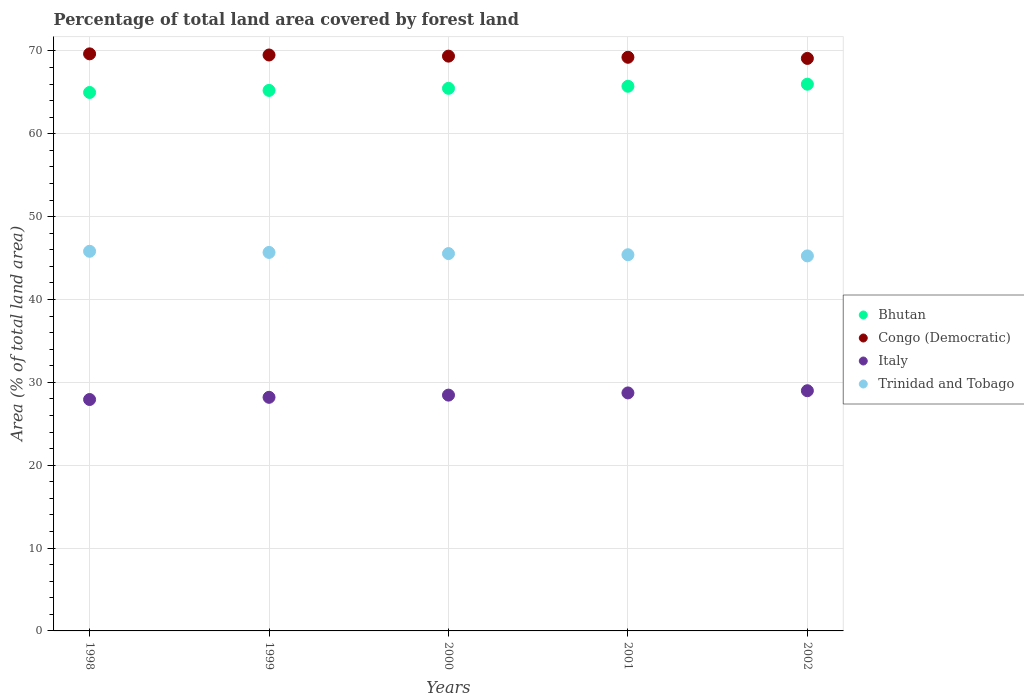What is the percentage of forest land in Congo (Democratic) in 1999?
Offer a terse response. 69.5. Across all years, what is the maximum percentage of forest land in Italy?
Your response must be concise. 28.99. Across all years, what is the minimum percentage of forest land in Bhutan?
Offer a terse response. 64.98. In which year was the percentage of forest land in Trinidad and Tobago maximum?
Your answer should be compact. 1998. In which year was the percentage of forest land in Bhutan minimum?
Offer a very short reply. 1998. What is the total percentage of forest land in Italy in the graph?
Your answer should be compact. 142.28. What is the difference between the percentage of forest land in Italy in 1999 and that in 2002?
Your answer should be very brief. -0.8. What is the difference between the percentage of forest land in Italy in 1998 and the percentage of forest land in Bhutan in 1999?
Provide a short and direct response. -37.3. What is the average percentage of forest land in Bhutan per year?
Your response must be concise. 65.48. In the year 1998, what is the difference between the percentage of forest land in Bhutan and percentage of forest land in Congo (Democratic)?
Provide a short and direct response. -4.66. What is the ratio of the percentage of forest land in Congo (Democratic) in 1998 to that in 2002?
Provide a short and direct response. 1.01. What is the difference between the highest and the second highest percentage of forest land in Congo (Democratic)?
Keep it short and to the point. 0.14. What is the difference between the highest and the lowest percentage of forest land in Congo (Democratic)?
Offer a very short reply. 0.55. In how many years, is the percentage of forest land in Trinidad and Tobago greater than the average percentage of forest land in Trinidad and Tobago taken over all years?
Your answer should be compact. 3. Is it the case that in every year, the sum of the percentage of forest land in Trinidad and Tobago and percentage of forest land in Congo (Democratic)  is greater than the sum of percentage of forest land in Bhutan and percentage of forest land in Italy?
Offer a terse response. No. Is it the case that in every year, the sum of the percentage of forest land in Bhutan and percentage of forest land in Italy  is greater than the percentage of forest land in Congo (Democratic)?
Provide a succinct answer. Yes. Does the percentage of forest land in Bhutan monotonically increase over the years?
Your answer should be compact. Yes. Is the percentage of forest land in Trinidad and Tobago strictly less than the percentage of forest land in Congo (Democratic) over the years?
Give a very brief answer. Yes. Are the values on the major ticks of Y-axis written in scientific E-notation?
Ensure brevity in your answer.  No. Does the graph contain any zero values?
Ensure brevity in your answer.  No. Does the graph contain grids?
Give a very brief answer. Yes. Where does the legend appear in the graph?
Your answer should be very brief. Center right. What is the title of the graph?
Make the answer very short. Percentage of total land area covered by forest land. Does "Samoa" appear as one of the legend labels in the graph?
Provide a short and direct response. No. What is the label or title of the Y-axis?
Offer a terse response. Area (% of total land area). What is the Area (% of total land area) of Bhutan in 1998?
Keep it short and to the point. 64.98. What is the Area (% of total land area) in Congo (Democratic) in 1998?
Offer a very short reply. 69.64. What is the Area (% of total land area) in Italy in 1998?
Make the answer very short. 27.93. What is the Area (% of total land area) in Trinidad and Tobago in 1998?
Make the answer very short. 45.81. What is the Area (% of total land area) in Bhutan in 1999?
Your response must be concise. 65.23. What is the Area (% of total land area) in Congo (Democratic) in 1999?
Provide a succinct answer. 69.5. What is the Area (% of total land area) in Italy in 1999?
Offer a terse response. 28.19. What is the Area (% of total land area) in Trinidad and Tobago in 1999?
Offer a terse response. 45.67. What is the Area (% of total land area) in Bhutan in 2000?
Offer a terse response. 65.48. What is the Area (% of total land area) in Congo (Democratic) in 2000?
Ensure brevity in your answer.  69.36. What is the Area (% of total land area) of Italy in 2000?
Your response must be concise. 28.46. What is the Area (% of total land area) of Trinidad and Tobago in 2000?
Your response must be concise. 45.54. What is the Area (% of total land area) in Bhutan in 2001?
Your answer should be compact. 65.73. What is the Area (% of total land area) of Congo (Democratic) in 2001?
Provide a short and direct response. 69.23. What is the Area (% of total land area) of Italy in 2001?
Offer a very short reply. 28.72. What is the Area (% of total land area) in Trinidad and Tobago in 2001?
Make the answer very short. 45.4. What is the Area (% of total land area) in Bhutan in 2002?
Ensure brevity in your answer.  65.98. What is the Area (% of total land area) of Congo (Democratic) in 2002?
Your answer should be compact. 69.09. What is the Area (% of total land area) of Italy in 2002?
Your answer should be compact. 28.99. What is the Area (% of total land area) in Trinidad and Tobago in 2002?
Your answer should be compact. 45.26. Across all years, what is the maximum Area (% of total land area) in Bhutan?
Your answer should be very brief. 65.98. Across all years, what is the maximum Area (% of total land area) of Congo (Democratic)?
Ensure brevity in your answer.  69.64. Across all years, what is the maximum Area (% of total land area) in Italy?
Provide a short and direct response. 28.99. Across all years, what is the maximum Area (% of total land area) of Trinidad and Tobago?
Your answer should be very brief. 45.81. Across all years, what is the minimum Area (% of total land area) in Bhutan?
Provide a succinct answer. 64.98. Across all years, what is the minimum Area (% of total land area) of Congo (Democratic)?
Your answer should be compact. 69.09. Across all years, what is the minimum Area (% of total land area) of Italy?
Provide a short and direct response. 27.93. Across all years, what is the minimum Area (% of total land area) in Trinidad and Tobago?
Keep it short and to the point. 45.26. What is the total Area (% of total land area) in Bhutan in the graph?
Give a very brief answer. 327.39. What is the total Area (% of total land area) of Congo (Democratic) in the graph?
Offer a terse response. 346.81. What is the total Area (% of total land area) in Italy in the graph?
Give a very brief answer. 142.28. What is the total Area (% of total land area) of Trinidad and Tobago in the graph?
Make the answer very short. 227.67. What is the difference between the Area (% of total land area) of Bhutan in 1998 and that in 1999?
Make the answer very short. -0.25. What is the difference between the Area (% of total land area) in Congo (Democratic) in 1998 and that in 1999?
Offer a terse response. 0.14. What is the difference between the Area (% of total land area) of Italy in 1998 and that in 1999?
Your answer should be compact. -0.26. What is the difference between the Area (% of total land area) of Trinidad and Tobago in 1998 and that in 1999?
Give a very brief answer. 0.14. What is the difference between the Area (% of total land area) in Bhutan in 1998 and that in 2000?
Make the answer very short. -0.5. What is the difference between the Area (% of total land area) of Congo (Democratic) in 1998 and that in 2000?
Your answer should be compact. 0.27. What is the difference between the Area (% of total land area) of Italy in 1998 and that in 2000?
Give a very brief answer. -0.53. What is the difference between the Area (% of total land area) of Trinidad and Tobago in 1998 and that in 2000?
Offer a terse response. 0.28. What is the difference between the Area (% of total land area) in Bhutan in 1998 and that in 2001?
Your answer should be very brief. -0.75. What is the difference between the Area (% of total land area) of Congo (Democratic) in 1998 and that in 2001?
Your answer should be compact. 0.41. What is the difference between the Area (% of total land area) in Italy in 1998 and that in 2001?
Offer a terse response. -0.79. What is the difference between the Area (% of total land area) in Trinidad and Tobago in 1998 and that in 2001?
Your answer should be compact. 0.42. What is the difference between the Area (% of total land area) of Bhutan in 1998 and that in 2002?
Offer a terse response. -1. What is the difference between the Area (% of total land area) in Congo (Democratic) in 1998 and that in 2002?
Ensure brevity in your answer.  0.55. What is the difference between the Area (% of total land area) in Italy in 1998 and that in 2002?
Provide a succinct answer. -1.06. What is the difference between the Area (% of total land area) in Trinidad and Tobago in 1998 and that in 2002?
Offer a very short reply. 0.56. What is the difference between the Area (% of total land area) in Bhutan in 1999 and that in 2000?
Offer a terse response. -0.25. What is the difference between the Area (% of total land area) in Congo (Democratic) in 1999 and that in 2000?
Offer a very short reply. 0.14. What is the difference between the Area (% of total land area) of Italy in 1999 and that in 2000?
Keep it short and to the point. -0.26. What is the difference between the Area (% of total land area) in Trinidad and Tobago in 1999 and that in 2000?
Give a very brief answer. 0.14. What is the difference between the Area (% of total land area) in Bhutan in 1999 and that in 2001?
Provide a short and direct response. -0.5. What is the difference between the Area (% of total land area) in Congo (Democratic) in 1999 and that in 2001?
Keep it short and to the point. 0.27. What is the difference between the Area (% of total land area) in Italy in 1999 and that in 2001?
Give a very brief answer. -0.53. What is the difference between the Area (% of total land area) of Trinidad and Tobago in 1999 and that in 2001?
Your response must be concise. 0.28. What is the difference between the Area (% of total land area) of Bhutan in 1999 and that in 2002?
Make the answer very short. -0.75. What is the difference between the Area (% of total land area) of Congo (Democratic) in 1999 and that in 2002?
Keep it short and to the point. 0.41. What is the difference between the Area (% of total land area) of Italy in 1999 and that in 2002?
Provide a short and direct response. -0.8. What is the difference between the Area (% of total land area) of Trinidad and Tobago in 1999 and that in 2002?
Keep it short and to the point. 0.42. What is the difference between the Area (% of total land area) of Bhutan in 2000 and that in 2001?
Ensure brevity in your answer.  -0.25. What is the difference between the Area (% of total land area) in Congo (Democratic) in 2000 and that in 2001?
Your response must be concise. 0.14. What is the difference between the Area (% of total land area) of Italy in 2000 and that in 2001?
Your response must be concise. -0.27. What is the difference between the Area (% of total land area) in Trinidad and Tobago in 2000 and that in 2001?
Your answer should be compact. 0.14. What is the difference between the Area (% of total land area) in Bhutan in 2000 and that in 2002?
Give a very brief answer. -0.5. What is the difference between the Area (% of total land area) in Congo (Democratic) in 2000 and that in 2002?
Offer a terse response. 0.27. What is the difference between the Area (% of total land area) of Italy in 2000 and that in 2002?
Keep it short and to the point. -0.53. What is the difference between the Area (% of total land area) in Trinidad and Tobago in 2000 and that in 2002?
Provide a short and direct response. 0.28. What is the difference between the Area (% of total land area) of Bhutan in 2001 and that in 2002?
Provide a short and direct response. -0.25. What is the difference between the Area (% of total land area) in Congo (Democratic) in 2001 and that in 2002?
Offer a very short reply. 0.14. What is the difference between the Area (% of total land area) in Italy in 2001 and that in 2002?
Give a very brief answer. -0.27. What is the difference between the Area (% of total land area) in Trinidad and Tobago in 2001 and that in 2002?
Your answer should be compact. 0.14. What is the difference between the Area (% of total land area) of Bhutan in 1998 and the Area (% of total land area) of Congo (Democratic) in 1999?
Make the answer very short. -4.52. What is the difference between the Area (% of total land area) in Bhutan in 1998 and the Area (% of total land area) in Italy in 1999?
Keep it short and to the point. 36.79. What is the difference between the Area (% of total land area) in Bhutan in 1998 and the Area (% of total land area) in Trinidad and Tobago in 1999?
Your answer should be very brief. 19.3. What is the difference between the Area (% of total land area) in Congo (Democratic) in 1998 and the Area (% of total land area) in Italy in 1999?
Your answer should be compact. 41.45. What is the difference between the Area (% of total land area) of Congo (Democratic) in 1998 and the Area (% of total land area) of Trinidad and Tobago in 1999?
Your answer should be compact. 23.96. What is the difference between the Area (% of total land area) of Italy in 1998 and the Area (% of total land area) of Trinidad and Tobago in 1999?
Provide a succinct answer. -17.75. What is the difference between the Area (% of total land area) of Bhutan in 1998 and the Area (% of total land area) of Congo (Democratic) in 2000?
Provide a succinct answer. -4.38. What is the difference between the Area (% of total land area) of Bhutan in 1998 and the Area (% of total land area) of Italy in 2000?
Provide a short and direct response. 36.52. What is the difference between the Area (% of total land area) in Bhutan in 1998 and the Area (% of total land area) in Trinidad and Tobago in 2000?
Offer a terse response. 19.44. What is the difference between the Area (% of total land area) in Congo (Democratic) in 1998 and the Area (% of total land area) in Italy in 2000?
Make the answer very short. 41.18. What is the difference between the Area (% of total land area) of Congo (Democratic) in 1998 and the Area (% of total land area) of Trinidad and Tobago in 2000?
Provide a short and direct response. 24.1. What is the difference between the Area (% of total land area) of Italy in 1998 and the Area (% of total land area) of Trinidad and Tobago in 2000?
Offer a very short reply. -17.61. What is the difference between the Area (% of total land area) of Bhutan in 1998 and the Area (% of total land area) of Congo (Democratic) in 2001?
Ensure brevity in your answer.  -4.25. What is the difference between the Area (% of total land area) in Bhutan in 1998 and the Area (% of total land area) in Italy in 2001?
Give a very brief answer. 36.26. What is the difference between the Area (% of total land area) in Bhutan in 1998 and the Area (% of total land area) in Trinidad and Tobago in 2001?
Provide a short and direct response. 19.58. What is the difference between the Area (% of total land area) of Congo (Democratic) in 1998 and the Area (% of total land area) of Italy in 2001?
Your answer should be compact. 40.92. What is the difference between the Area (% of total land area) in Congo (Democratic) in 1998 and the Area (% of total land area) in Trinidad and Tobago in 2001?
Provide a short and direct response. 24.24. What is the difference between the Area (% of total land area) of Italy in 1998 and the Area (% of total land area) of Trinidad and Tobago in 2001?
Give a very brief answer. -17.47. What is the difference between the Area (% of total land area) in Bhutan in 1998 and the Area (% of total land area) in Congo (Democratic) in 2002?
Offer a terse response. -4.11. What is the difference between the Area (% of total land area) of Bhutan in 1998 and the Area (% of total land area) of Italy in 2002?
Your answer should be very brief. 35.99. What is the difference between the Area (% of total land area) in Bhutan in 1998 and the Area (% of total land area) in Trinidad and Tobago in 2002?
Your answer should be very brief. 19.72. What is the difference between the Area (% of total land area) in Congo (Democratic) in 1998 and the Area (% of total land area) in Italy in 2002?
Your answer should be compact. 40.65. What is the difference between the Area (% of total land area) of Congo (Democratic) in 1998 and the Area (% of total land area) of Trinidad and Tobago in 2002?
Your answer should be compact. 24.38. What is the difference between the Area (% of total land area) of Italy in 1998 and the Area (% of total land area) of Trinidad and Tobago in 2002?
Offer a terse response. -17.33. What is the difference between the Area (% of total land area) of Bhutan in 1999 and the Area (% of total land area) of Congo (Democratic) in 2000?
Offer a very short reply. -4.13. What is the difference between the Area (% of total land area) of Bhutan in 1999 and the Area (% of total land area) of Italy in 2000?
Provide a short and direct response. 36.77. What is the difference between the Area (% of total land area) in Bhutan in 1999 and the Area (% of total land area) in Trinidad and Tobago in 2000?
Your answer should be compact. 19.69. What is the difference between the Area (% of total land area) of Congo (Democratic) in 1999 and the Area (% of total land area) of Italy in 2000?
Offer a terse response. 41.04. What is the difference between the Area (% of total land area) in Congo (Democratic) in 1999 and the Area (% of total land area) in Trinidad and Tobago in 2000?
Your response must be concise. 23.96. What is the difference between the Area (% of total land area) of Italy in 1999 and the Area (% of total land area) of Trinidad and Tobago in 2000?
Your answer should be very brief. -17.35. What is the difference between the Area (% of total land area) of Bhutan in 1999 and the Area (% of total land area) of Congo (Democratic) in 2001?
Provide a short and direct response. -4. What is the difference between the Area (% of total land area) in Bhutan in 1999 and the Area (% of total land area) in Italy in 2001?
Make the answer very short. 36.51. What is the difference between the Area (% of total land area) in Bhutan in 1999 and the Area (% of total land area) in Trinidad and Tobago in 2001?
Make the answer very short. 19.83. What is the difference between the Area (% of total land area) of Congo (Democratic) in 1999 and the Area (% of total land area) of Italy in 2001?
Give a very brief answer. 40.78. What is the difference between the Area (% of total land area) in Congo (Democratic) in 1999 and the Area (% of total land area) in Trinidad and Tobago in 2001?
Provide a succinct answer. 24.1. What is the difference between the Area (% of total land area) of Italy in 1999 and the Area (% of total land area) of Trinidad and Tobago in 2001?
Offer a terse response. -17.21. What is the difference between the Area (% of total land area) of Bhutan in 1999 and the Area (% of total land area) of Congo (Democratic) in 2002?
Your answer should be compact. -3.86. What is the difference between the Area (% of total land area) of Bhutan in 1999 and the Area (% of total land area) of Italy in 2002?
Make the answer very short. 36.24. What is the difference between the Area (% of total land area) of Bhutan in 1999 and the Area (% of total land area) of Trinidad and Tobago in 2002?
Provide a short and direct response. 19.97. What is the difference between the Area (% of total land area) in Congo (Democratic) in 1999 and the Area (% of total land area) in Italy in 2002?
Keep it short and to the point. 40.51. What is the difference between the Area (% of total land area) in Congo (Democratic) in 1999 and the Area (% of total land area) in Trinidad and Tobago in 2002?
Ensure brevity in your answer.  24.24. What is the difference between the Area (% of total land area) in Italy in 1999 and the Area (% of total land area) in Trinidad and Tobago in 2002?
Your response must be concise. -17.06. What is the difference between the Area (% of total land area) in Bhutan in 2000 and the Area (% of total land area) in Congo (Democratic) in 2001?
Keep it short and to the point. -3.75. What is the difference between the Area (% of total land area) of Bhutan in 2000 and the Area (% of total land area) of Italy in 2001?
Ensure brevity in your answer.  36.76. What is the difference between the Area (% of total land area) of Bhutan in 2000 and the Area (% of total land area) of Trinidad and Tobago in 2001?
Offer a terse response. 20.08. What is the difference between the Area (% of total land area) in Congo (Democratic) in 2000 and the Area (% of total land area) in Italy in 2001?
Offer a terse response. 40.64. What is the difference between the Area (% of total land area) of Congo (Democratic) in 2000 and the Area (% of total land area) of Trinidad and Tobago in 2001?
Make the answer very short. 23.97. What is the difference between the Area (% of total land area) in Italy in 2000 and the Area (% of total land area) in Trinidad and Tobago in 2001?
Provide a short and direct response. -16.94. What is the difference between the Area (% of total land area) in Bhutan in 2000 and the Area (% of total land area) in Congo (Democratic) in 2002?
Provide a short and direct response. -3.61. What is the difference between the Area (% of total land area) in Bhutan in 2000 and the Area (% of total land area) in Italy in 2002?
Your answer should be very brief. 36.49. What is the difference between the Area (% of total land area) of Bhutan in 2000 and the Area (% of total land area) of Trinidad and Tobago in 2002?
Your answer should be compact. 20.22. What is the difference between the Area (% of total land area) in Congo (Democratic) in 2000 and the Area (% of total land area) in Italy in 2002?
Give a very brief answer. 40.38. What is the difference between the Area (% of total land area) in Congo (Democratic) in 2000 and the Area (% of total land area) in Trinidad and Tobago in 2002?
Ensure brevity in your answer.  24.11. What is the difference between the Area (% of total land area) in Italy in 2000 and the Area (% of total land area) in Trinidad and Tobago in 2002?
Ensure brevity in your answer.  -16.8. What is the difference between the Area (% of total land area) of Bhutan in 2001 and the Area (% of total land area) of Congo (Democratic) in 2002?
Offer a very short reply. -3.36. What is the difference between the Area (% of total land area) of Bhutan in 2001 and the Area (% of total land area) of Italy in 2002?
Keep it short and to the point. 36.74. What is the difference between the Area (% of total land area) in Bhutan in 2001 and the Area (% of total land area) in Trinidad and Tobago in 2002?
Give a very brief answer. 20.47. What is the difference between the Area (% of total land area) in Congo (Democratic) in 2001 and the Area (% of total land area) in Italy in 2002?
Keep it short and to the point. 40.24. What is the difference between the Area (% of total land area) of Congo (Democratic) in 2001 and the Area (% of total land area) of Trinidad and Tobago in 2002?
Offer a terse response. 23.97. What is the difference between the Area (% of total land area) of Italy in 2001 and the Area (% of total land area) of Trinidad and Tobago in 2002?
Ensure brevity in your answer.  -16.53. What is the average Area (% of total land area) in Bhutan per year?
Give a very brief answer. 65.48. What is the average Area (% of total land area) in Congo (Democratic) per year?
Give a very brief answer. 69.36. What is the average Area (% of total land area) of Italy per year?
Make the answer very short. 28.46. What is the average Area (% of total land area) in Trinidad and Tobago per year?
Offer a terse response. 45.53. In the year 1998, what is the difference between the Area (% of total land area) in Bhutan and Area (% of total land area) in Congo (Democratic)?
Your response must be concise. -4.66. In the year 1998, what is the difference between the Area (% of total land area) in Bhutan and Area (% of total land area) in Italy?
Offer a terse response. 37.05. In the year 1998, what is the difference between the Area (% of total land area) in Bhutan and Area (% of total land area) in Trinidad and Tobago?
Your response must be concise. 19.17. In the year 1998, what is the difference between the Area (% of total land area) in Congo (Democratic) and Area (% of total land area) in Italy?
Your response must be concise. 41.71. In the year 1998, what is the difference between the Area (% of total land area) of Congo (Democratic) and Area (% of total land area) of Trinidad and Tobago?
Keep it short and to the point. 23.82. In the year 1998, what is the difference between the Area (% of total land area) of Italy and Area (% of total land area) of Trinidad and Tobago?
Ensure brevity in your answer.  -17.89. In the year 1999, what is the difference between the Area (% of total land area) in Bhutan and Area (% of total land area) in Congo (Democratic)?
Make the answer very short. -4.27. In the year 1999, what is the difference between the Area (% of total land area) in Bhutan and Area (% of total land area) in Italy?
Give a very brief answer. 37.04. In the year 1999, what is the difference between the Area (% of total land area) of Bhutan and Area (% of total land area) of Trinidad and Tobago?
Offer a very short reply. 19.55. In the year 1999, what is the difference between the Area (% of total land area) of Congo (Democratic) and Area (% of total land area) of Italy?
Your answer should be very brief. 41.31. In the year 1999, what is the difference between the Area (% of total land area) in Congo (Democratic) and Area (% of total land area) in Trinidad and Tobago?
Your response must be concise. 23.83. In the year 1999, what is the difference between the Area (% of total land area) in Italy and Area (% of total land area) in Trinidad and Tobago?
Offer a very short reply. -17.48. In the year 2000, what is the difference between the Area (% of total land area) in Bhutan and Area (% of total land area) in Congo (Democratic)?
Your answer should be very brief. -3.89. In the year 2000, what is the difference between the Area (% of total land area) in Bhutan and Area (% of total land area) in Italy?
Offer a terse response. 37.02. In the year 2000, what is the difference between the Area (% of total land area) of Bhutan and Area (% of total land area) of Trinidad and Tobago?
Your response must be concise. 19.94. In the year 2000, what is the difference between the Area (% of total land area) of Congo (Democratic) and Area (% of total land area) of Italy?
Make the answer very short. 40.91. In the year 2000, what is the difference between the Area (% of total land area) of Congo (Democratic) and Area (% of total land area) of Trinidad and Tobago?
Your answer should be compact. 23.83. In the year 2000, what is the difference between the Area (% of total land area) of Italy and Area (% of total land area) of Trinidad and Tobago?
Your answer should be very brief. -17.08. In the year 2001, what is the difference between the Area (% of total land area) of Bhutan and Area (% of total land area) of Congo (Democratic)?
Ensure brevity in your answer.  -3.5. In the year 2001, what is the difference between the Area (% of total land area) in Bhutan and Area (% of total land area) in Italy?
Make the answer very short. 37.01. In the year 2001, what is the difference between the Area (% of total land area) in Bhutan and Area (% of total land area) in Trinidad and Tobago?
Your answer should be compact. 20.33. In the year 2001, what is the difference between the Area (% of total land area) in Congo (Democratic) and Area (% of total land area) in Italy?
Give a very brief answer. 40.5. In the year 2001, what is the difference between the Area (% of total land area) in Congo (Democratic) and Area (% of total land area) in Trinidad and Tobago?
Make the answer very short. 23.83. In the year 2001, what is the difference between the Area (% of total land area) in Italy and Area (% of total land area) in Trinidad and Tobago?
Provide a succinct answer. -16.68. In the year 2002, what is the difference between the Area (% of total land area) of Bhutan and Area (% of total land area) of Congo (Democratic)?
Your answer should be very brief. -3.11. In the year 2002, what is the difference between the Area (% of total land area) in Bhutan and Area (% of total land area) in Italy?
Your response must be concise. 36.99. In the year 2002, what is the difference between the Area (% of total land area) in Bhutan and Area (% of total land area) in Trinidad and Tobago?
Your answer should be very brief. 20.72. In the year 2002, what is the difference between the Area (% of total land area) of Congo (Democratic) and Area (% of total land area) of Italy?
Your answer should be compact. 40.1. In the year 2002, what is the difference between the Area (% of total land area) in Congo (Democratic) and Area (% of total land area) in Trinidad and Tobago?
Make the answer very short. 23.83. In the year 2002, what is the difference between the Area (% of total land area) of Italy and Area (% of total land area) of Trinidad and Tobago?
Offer a terse response. -16.27. What is the ratio of the Area (% of total land area) of Italy in 1998 to that in 1999?
Your answer should be compact. 0.99. What is the ratio of the Area (% of total land area) of Trinidad and Tobago in 1998 to that in 1999?
Ensure brevity in your answer.  1. What is the ratio of the Area (% of total land area) of Bhutan in 1998 to that in 2000?
Offer a terse response. 0.99. What is the ratio of the Area (% of total land area) in Italy in 1998 to that in 2000?
Provide a short and direct response. 0.98. What is the ratio of the Area (% of total land area) in Trinidad and Tobago in 1998 to that in 2000?
Keep it short and to the point. 1.01. What is the ratio of the Area (% of total land area) of Italy in 1998 to that in 2001?
Keep it short and to the point. 0.97. What is the ratio of the Area (% of total land area) in Trinidad and Tobago in 1998 to that in 2001?
Provide a short and direct response. 1.01. What is the ratio of the Area (% of total land area) of Bhutan in 1998 to that in 2002?
Your response must be concise. 0.98. What is the ratio of the Area (% of total land area) of Italy in 1998 to that in 2002?
Offer a very short reply. 0.96. What is the ratio of the Area (% of total land area) of Trinidad and Tobago in 1998 to that in 2002?
Offer a very short reply. 1.01. What is the ratio of the Area (% of total land area) of Bhutan in 1999 to that in 2000?
Make the answer very short. 1. What is the ratio of the Area (% of total land area) of Congo (Democratic) in 1999 to that in 2000?
Your answer should be very brief. 1. What is the ratio of the Area (% of total land area) of Trinidad and Tobago in 1999 to that in 2000?
Offer a terse response. 1. What is the ratio of the Area (% of total land area) of Congo (Democratic) in 1999 to that in 2001?
Provide a succinct answer. 1. What is the ratio of the Area (% of total land area) in Italy in 1999 to that in 2001?
Your answer should be very brief. 0.98. What is the ratio of the Area (% of total land area) in Bhutan in 1999 to that in 2002?
Make the answer very short. 0.99. What is the ratio of the Area (% of total land area) of Congo (Democratic) in 1999 to that in 2002?
Your answer should be very brief. 1.01. What is the ratio of the Area (% of total land area) of Italy in 1999 to that in 2002?
Keep it short and to the point. 0.97. What is the ratio of the Area (% of total land area) in Trinidad and Tobago in 1999 to that in 2002?
Provide a short and direct response. 1.01. What is the ratio of the Area (% of total land area) in Italy in 2000 to that in 2001?
Offer a terse response. 0.99. What is the ratio of the Area (% of total land area) of Trinidad and Tobago in 2000 to that in 2001?
Offer a terse response. 1. What is the ratio of the Area (% of total land area) of Bhutan in 2000 to that in 2002?
Offer a very short reply. 0.99. What is the ratio of the Area (% of total land area) in Congo (Democratic) in 2000 to that in 2002?
Offer a very short reply. 1. What is the ratio of the Area (% of total land area) of Italy in 2000 to that in 2002?
Your answer should be very brief. 0.98. What is the ratio of the Area (% of total land area) of Congo (Democratic) in 2001 to that in 2002?
Your answer should be compact. 1. What is the ratio of the Area (% of total land area) of Italy in 2001 to that in 2002?
Make the answer very short. 0.99. What is the difference between the highest and the second highest Area (% of total land area) of Bhutan?
Give a very brief answer. 0.25. What is the difference between the highest and the second highest Area (% of total land area) in Congo (Democratic)?
Ensure brevity in your answer.  0.14. What is the difference between the highest and the second highest Area (% of total land area) in Italy?
Give a very brief answer. 0.27. What is the difference between the highest and the second highest Area (% of total land area) in Trinidad and Tobago?
Ensure brevity in your answer.  0.14. What is the difference between the highest and the lowest Area (% of total land area) in Congo (Democratic)?
Your answer should be compact. 0.55. What is the difference between the highest and the lowest Area (% of total land area) of Italy?
Keep it short and to the point. 1.06. What is the difference between the highest and the lowest Area (% of total land area) in Trinidad and Tobago?
Your response must be concise. 0.56. 